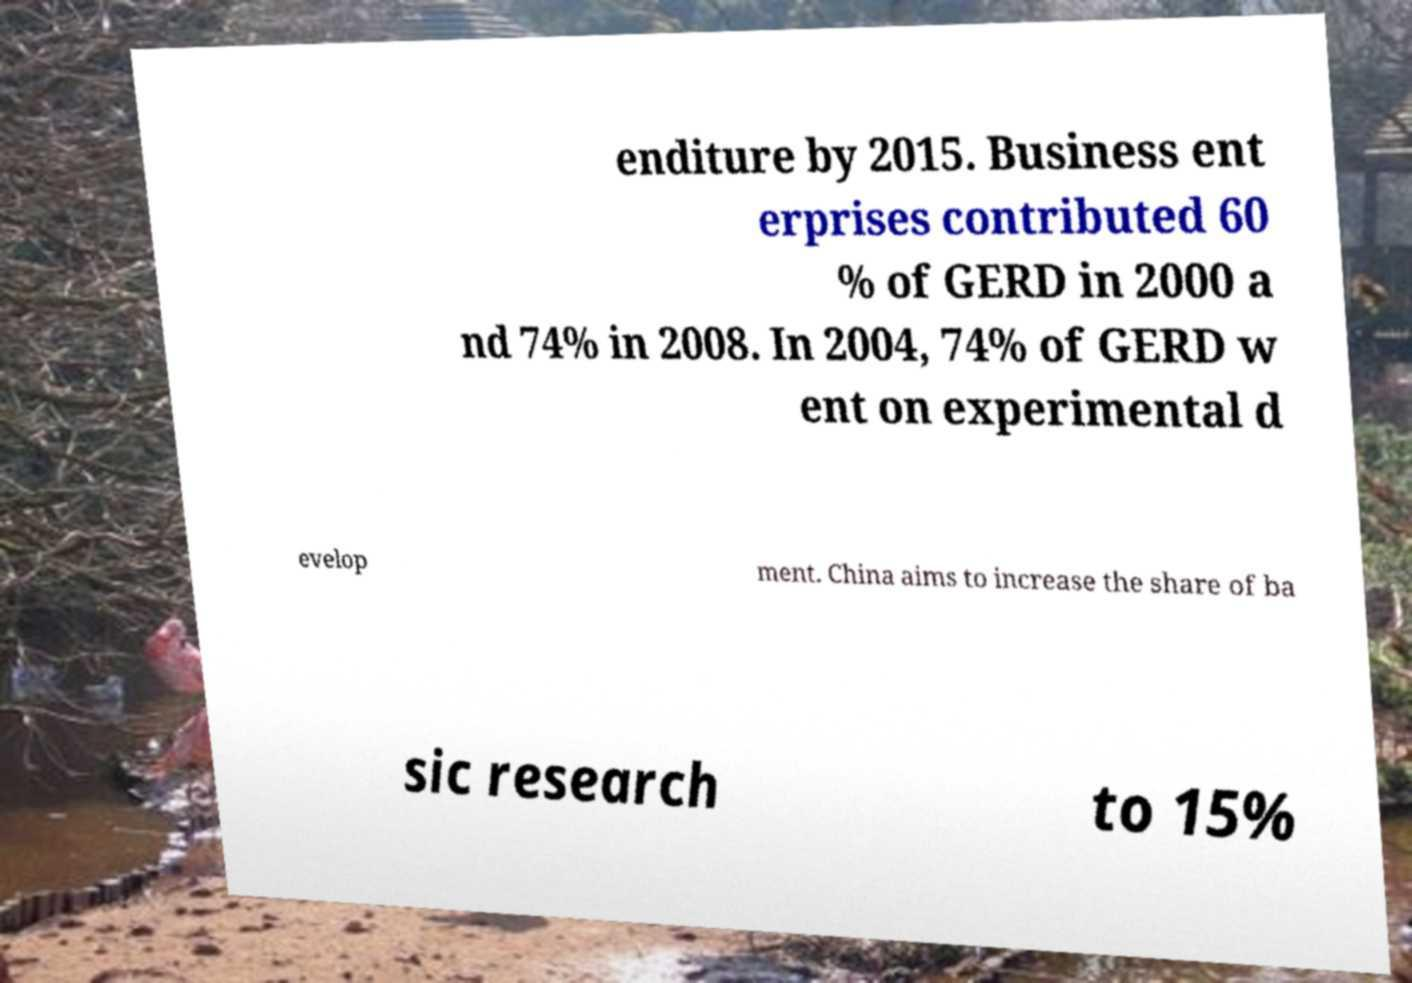Can you accurately transcribe the text from the provided image for me? enditure by 2015. Business ent erprises contributed 60 % of GERD in 2000 a nd 74% in 2008. In 2004, 74% of GERD w ent on experimental d evelop ment. China aims to increase the share of ba sic research to 15% 